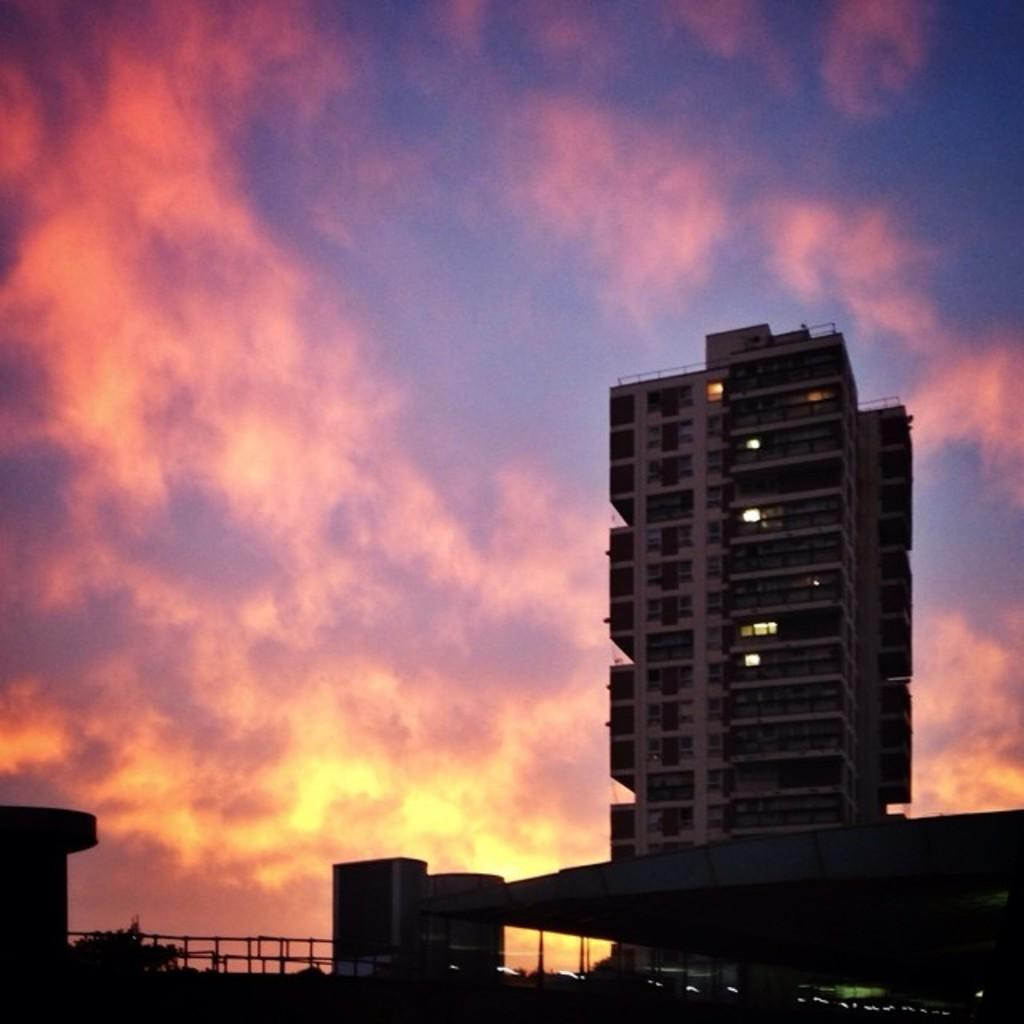What type of structures can be seen in the image? There are buildings in the image. What is the barrier surrounding the area in the image? There is a fence in the image. What type of plant is present in the image? There is a tree in the image. What is visible in the background of the image? The sky is visible in the background of the image. Where is the hydrant located in the image? There is no hydrant present in the image. What color is the mitten on the tree in the image? There is no mitten present in the image. 